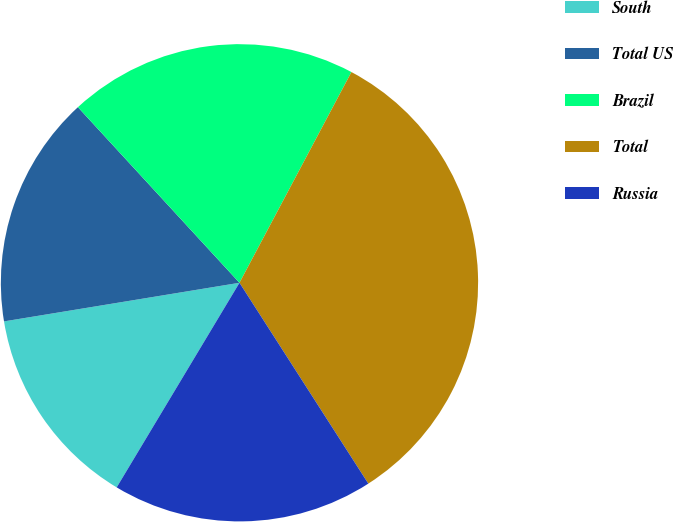Convert chart. <chart><loc_0><loc_0><loc_500><loc_500><pie_chart><fcel>South<fcel>Total US<fcel>Brazil<fcel>Total<fcel>Russia<nl><fcel>13.81%<fcel>15.75%<fcel>19.61%<fcel>33.15%<fcel>17.68%<nl></chart> 